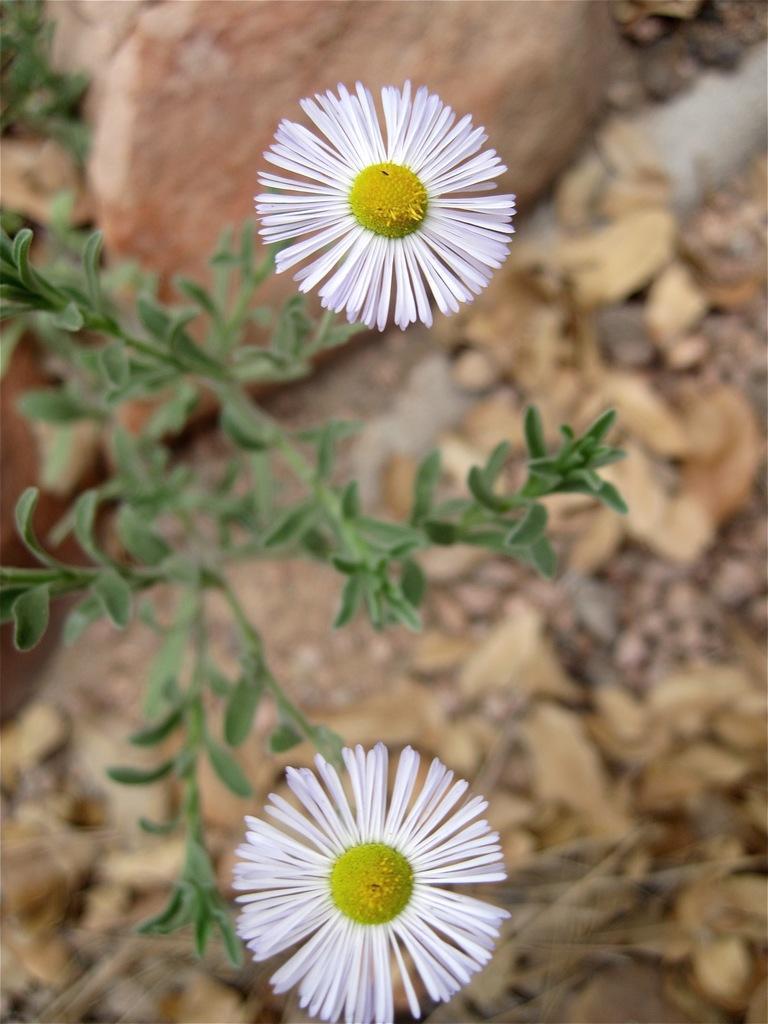Could you give a brief overview of what you see in this image? In the image we can see some flowers and plants. 